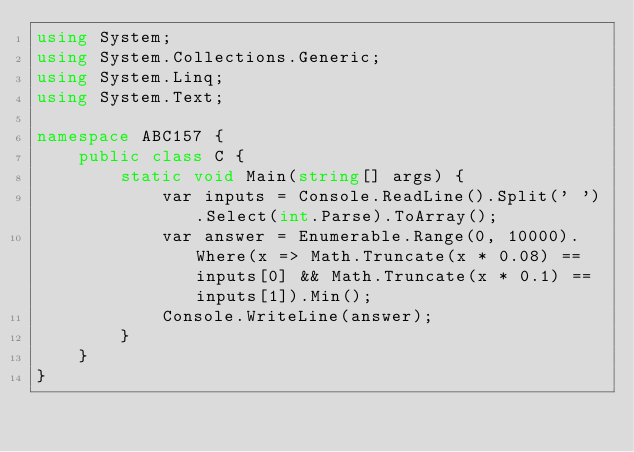<code> <loc_0><loc_0><loc_500><loc_500><_C#_>using System;
using System.Collections.Generic;
using System.Linq;
using System.Text;

namespace ABC157 {
    public class C {
        static void Main(string[] args) {
            var inputs = Console.ReadLine().Split(' ').Select(int.Parse).ToArray();
            var answer = Enumerable.Range(0, 10000).Where(x => Math.Truncate(x * 0.08) == inputs[0] && Math.Truncate(x * 0.1) == inputs[1]).Min();
            Console.WriteLine(answer);
        }
    }
}
</code> 